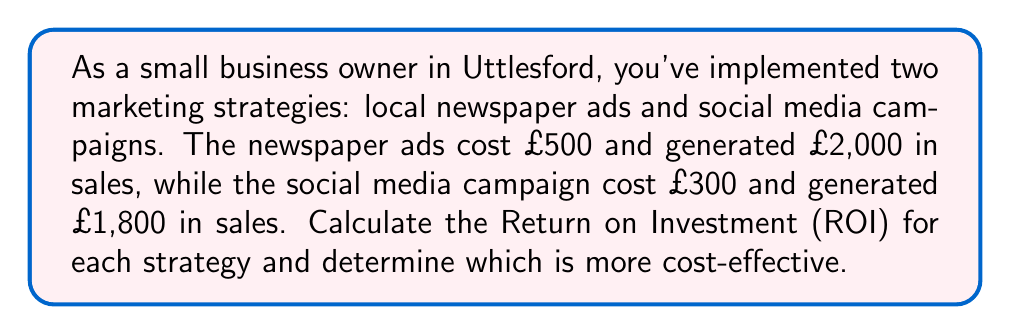Help me with this question. To solve this problem, we need to calculate the ROI for each marketing strategy and compare them. The formula for ROI is:

$$ ROI = \frac{\text{Net Profit}}{\text{Cost of Investment}} \times 100\% $$

Where Net Profit = Revenue - Cost of Investment

Step 1: Calculate ROI for newspaper ads
Revenue: £2,000
Cost: £500
Net Profit: £2,000 - £500 = £1,500

$$ ROI_{newspaper} = \frac{1500}{500} \times 100\% = 300\% $$

Step 2: Calculate ROI for social media campaign
Revenue: £1,800
Cost: £300
Net Profit: £1,800 - £300 = £1,500

$$ ROI_{social media} = \frac{1500}{300} \times 100\% = 500\% $$

Step 3: Compare the ROIs
The social media campaign has a higher ROI (500%) compared to the newspaper ads (300%), making it more cost-effective.
Answer: Social media campaign (ROI: 500%) 